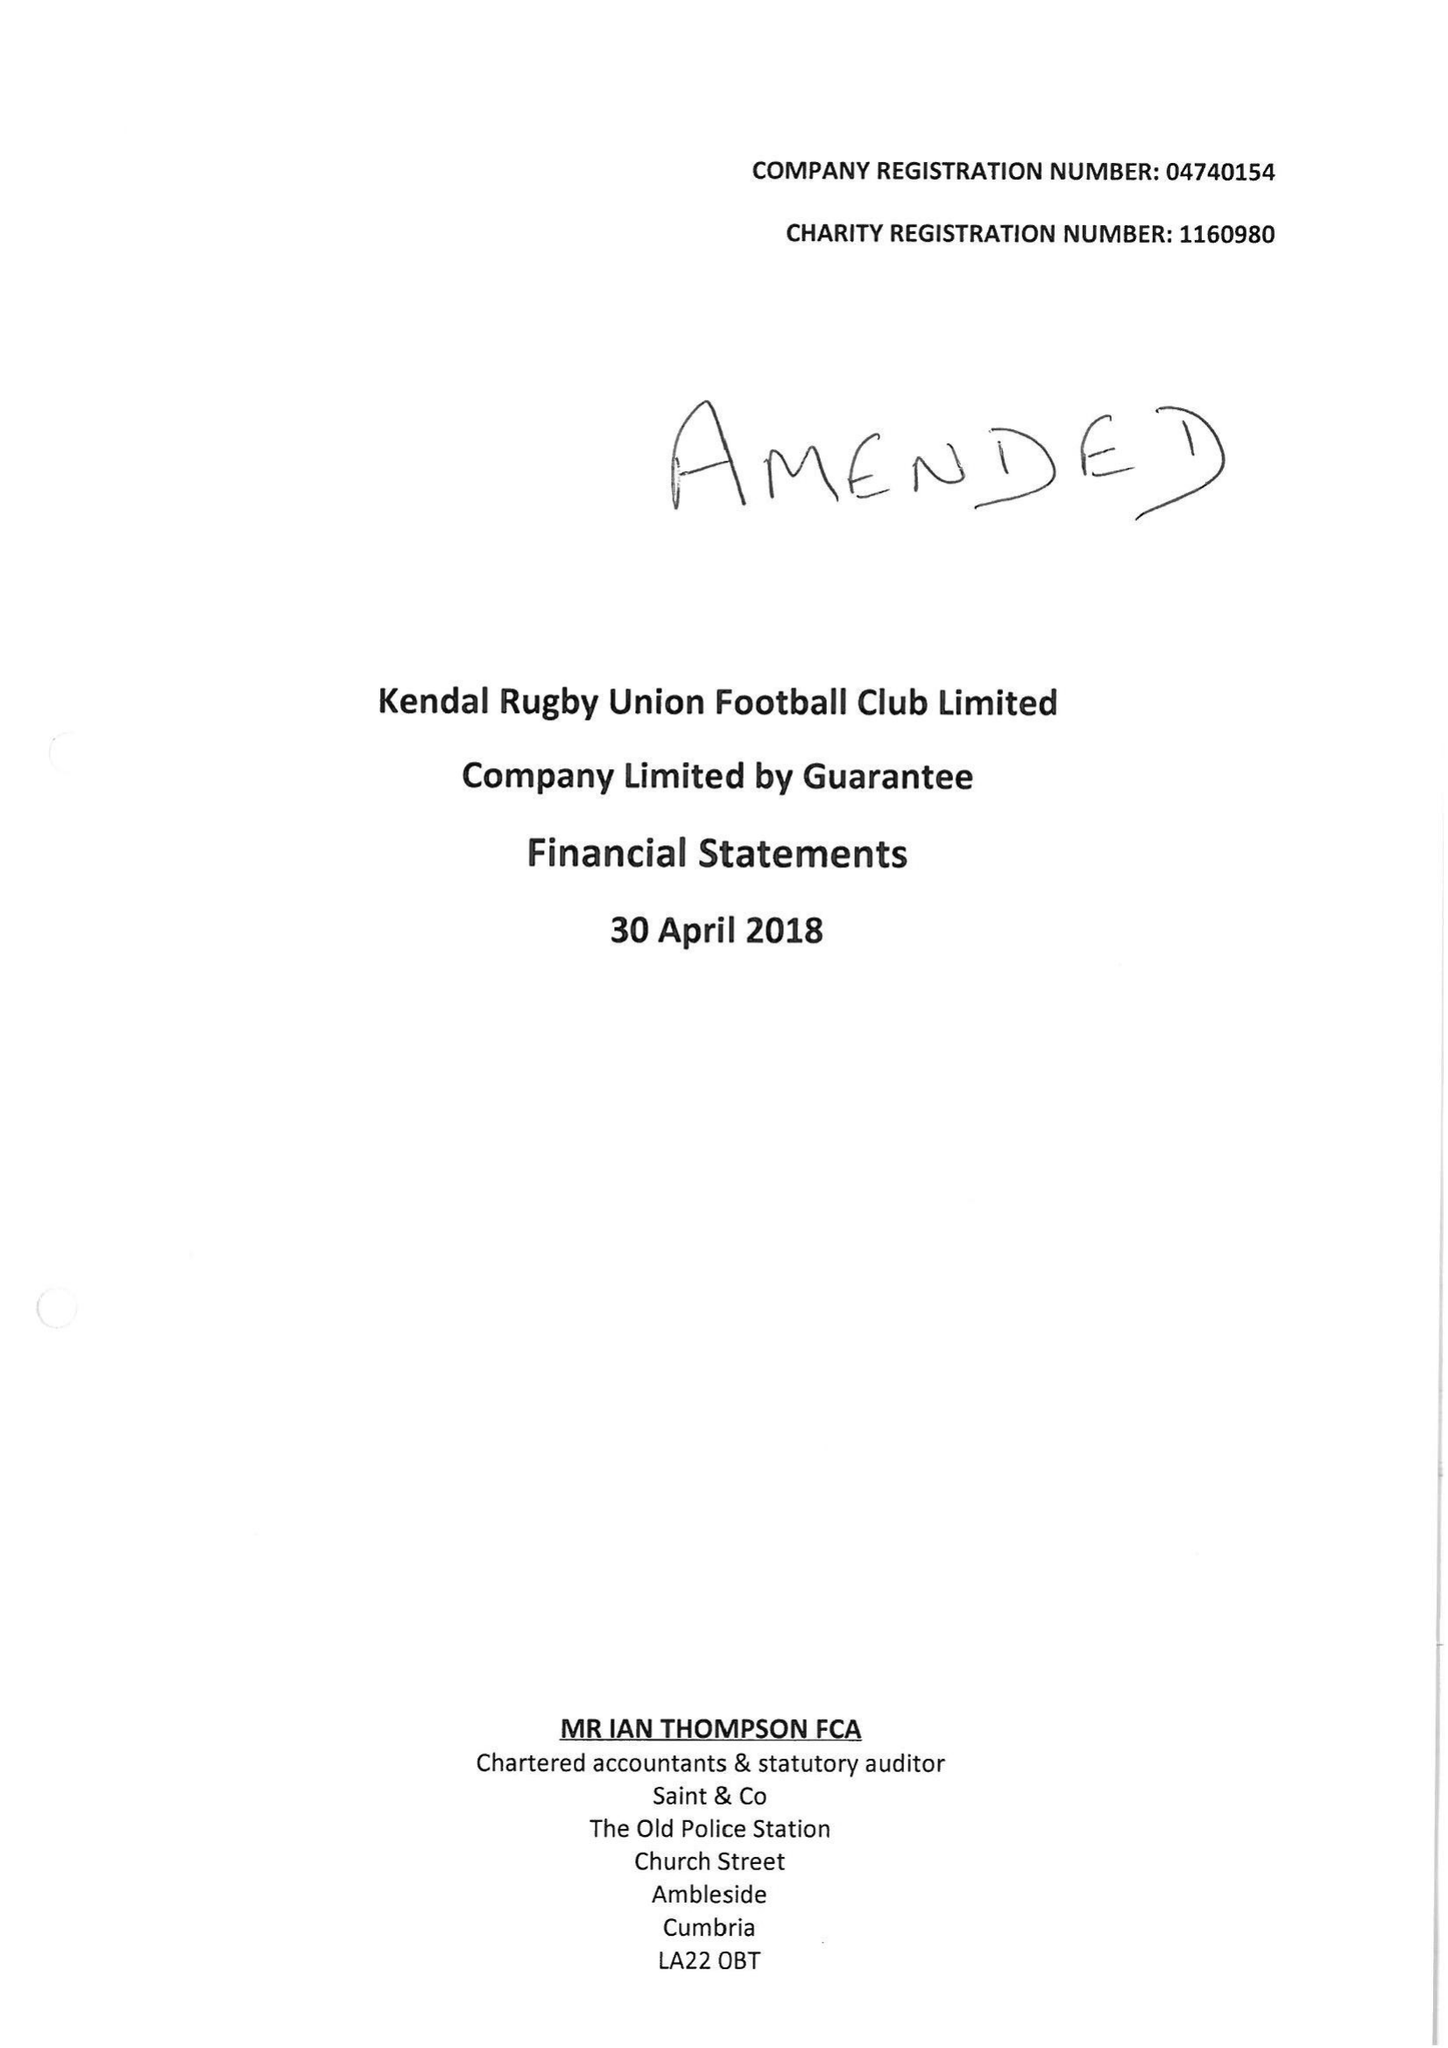What is the value for the report_date?
Answer the question using a single word or phrase. 2018-04-30 